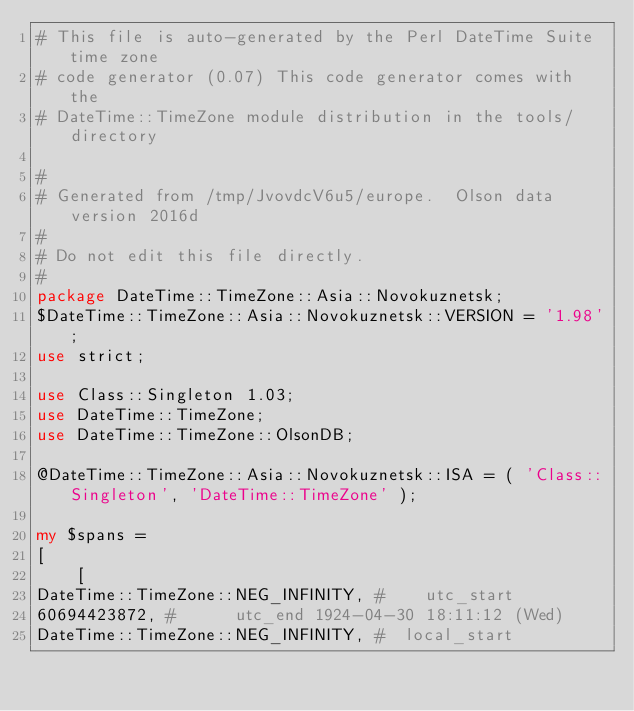Convert code to text. <code><loc_0><loc_0><loc_500><loc_500><_Perl_># This file is auto-generated by the Perl DateTime Suite time zone
# code generator (0.07) This code generator comes with the
# DateTime::TimeZone module distribution in the tools/ directory

#
# Generated from /tmp/JvovdcV6u5/europe.  Olson data version 2016d
#
# Do not edit this file directly.
#
package DateTime::TimeZone::Asia::Novokuznetsk;
$DateTime::TimeZone::Asia::Novokuznetsk::VERSION = '1.98';
use strict;

use Class::Singleton 1.03;
use DateTime::TimeZone;
use DateTime::TimeZone::OlsonDB;

@DateTime::TimeZone::Asia::Novokuznetsk::ISA = ( 'Class::Singleton', 'DateTime::TimeZone' );

my $spans =
[
    [
DateTime::TimeZone::NEG_INFINITY, #    utc_start
60694423872, #      utc_end 1924-04-30 18:11:12 (Wed)
DateTime::TimeZone::NEG_INFINITY, #  local_start</code> 